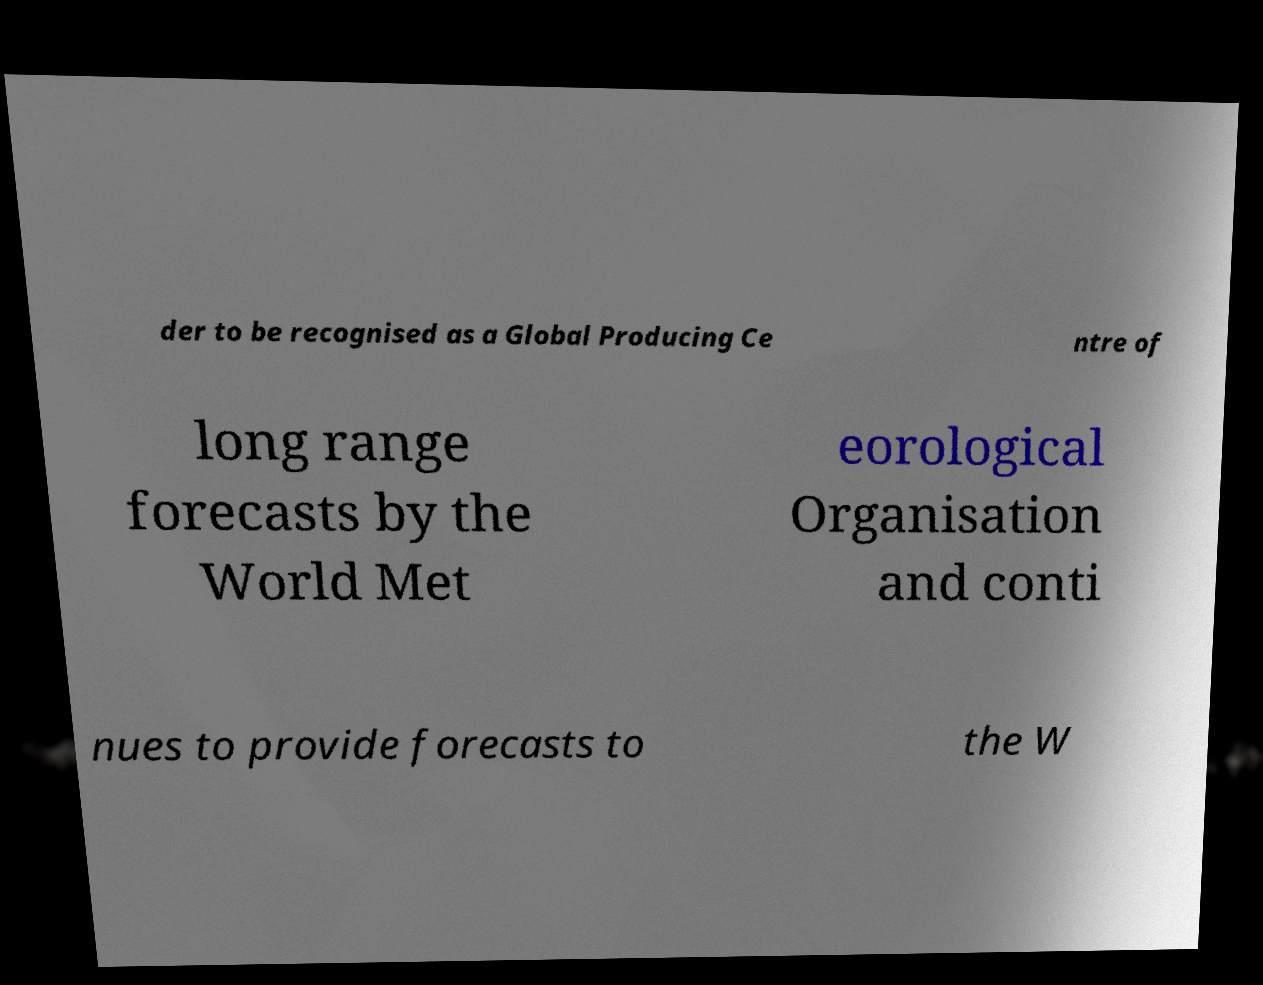Please read and relay the text visible in this image. What does it say? der to be recognised as a Global Producing Ce ntre of long range forecasts by the World Met eorological Organisation and conti nues to provide forecasts to the W 